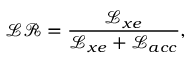<formula> <loc_0><loc_0><loc_500><loc_500>\mathcal { L R } = \frac { \mathcal { L } _ { x e } } { \mathcal { L } _ { x e } + \mathcal { L } _ { a c c } } ,</formula> 